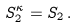<formula> <loc_0><loc_0><loc_500><loc_500>S ^ { \kappa } _ { 2 } = S _ { 2 } \, .</formula> 